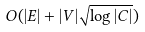Convert formula to latex. <formula><loc_0><loc_0><loc_500><loc_500>O ( | E | + | V | \sqrt { \log | C | } )</formula> 